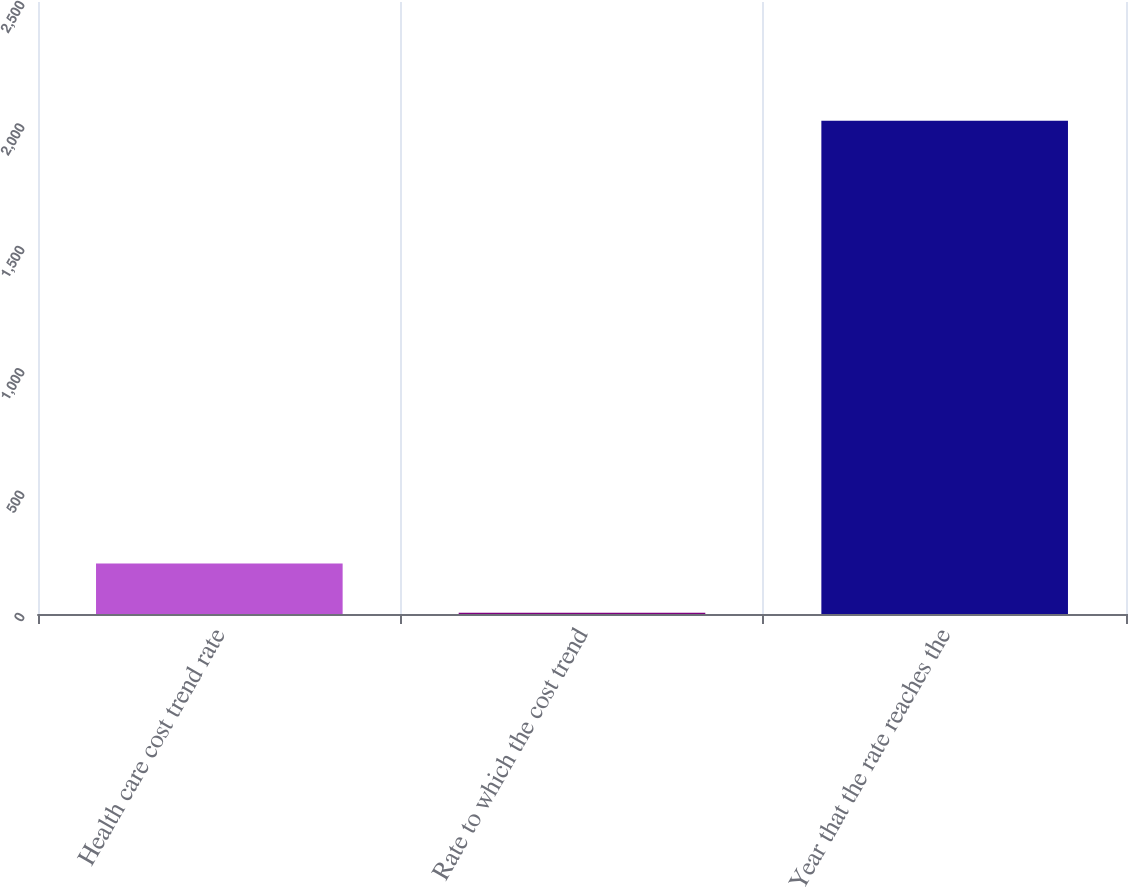Convert chart to OTSL. <chart><loc_0><loc_0><loc_500><loc_500><bar_chart><fcel>Health care cost trend rate<fcel>Rate to which the cost trend<fcel>Year that the rate reaches the<nl><fcel>206<fcel>5<fcel>2015<nl></chart> 